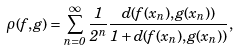<formula> <loc_0><loc_0><loc_500><loc_500>\rho ( f , g ) = \sum ^ { \infty } _ { n = 0 } \frac { 1 } { 2 ^ { n } } \frac { d ( f ( x _ { n } ) , g ( x _ { n } ) ) } { 1 + d ( f ( x _ { n } ) , g ( x _ { n } ) ) } ,</formula> 